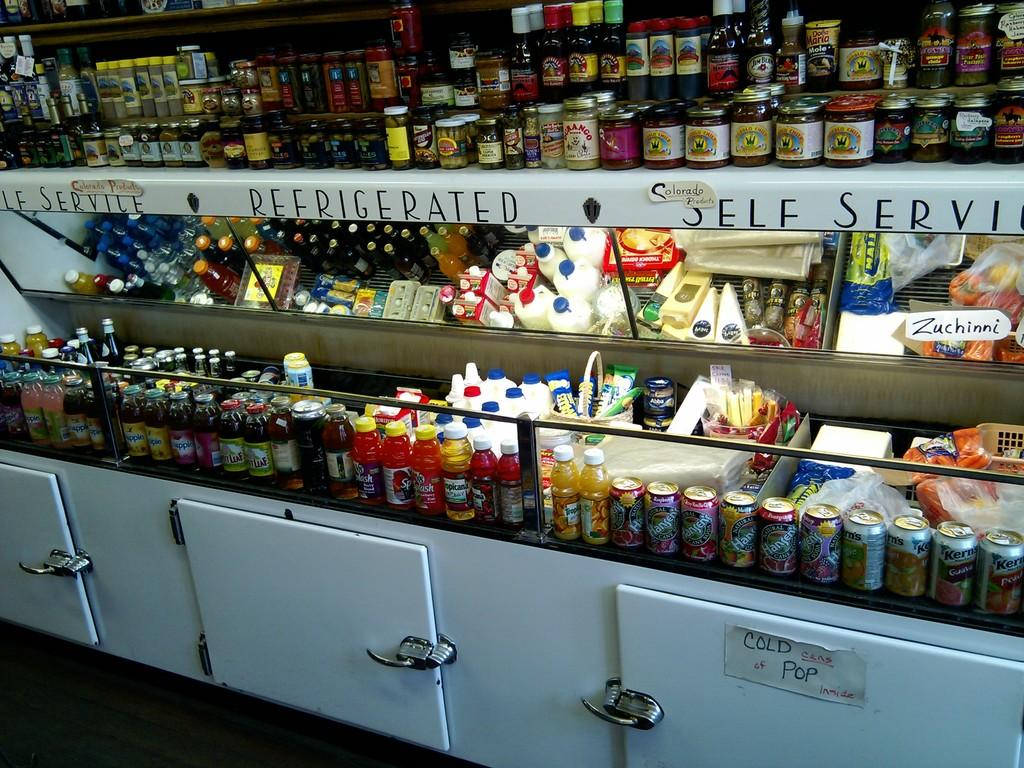<image>
Summarize the visual content of the image. Refrigerated self service section in a grocery store 